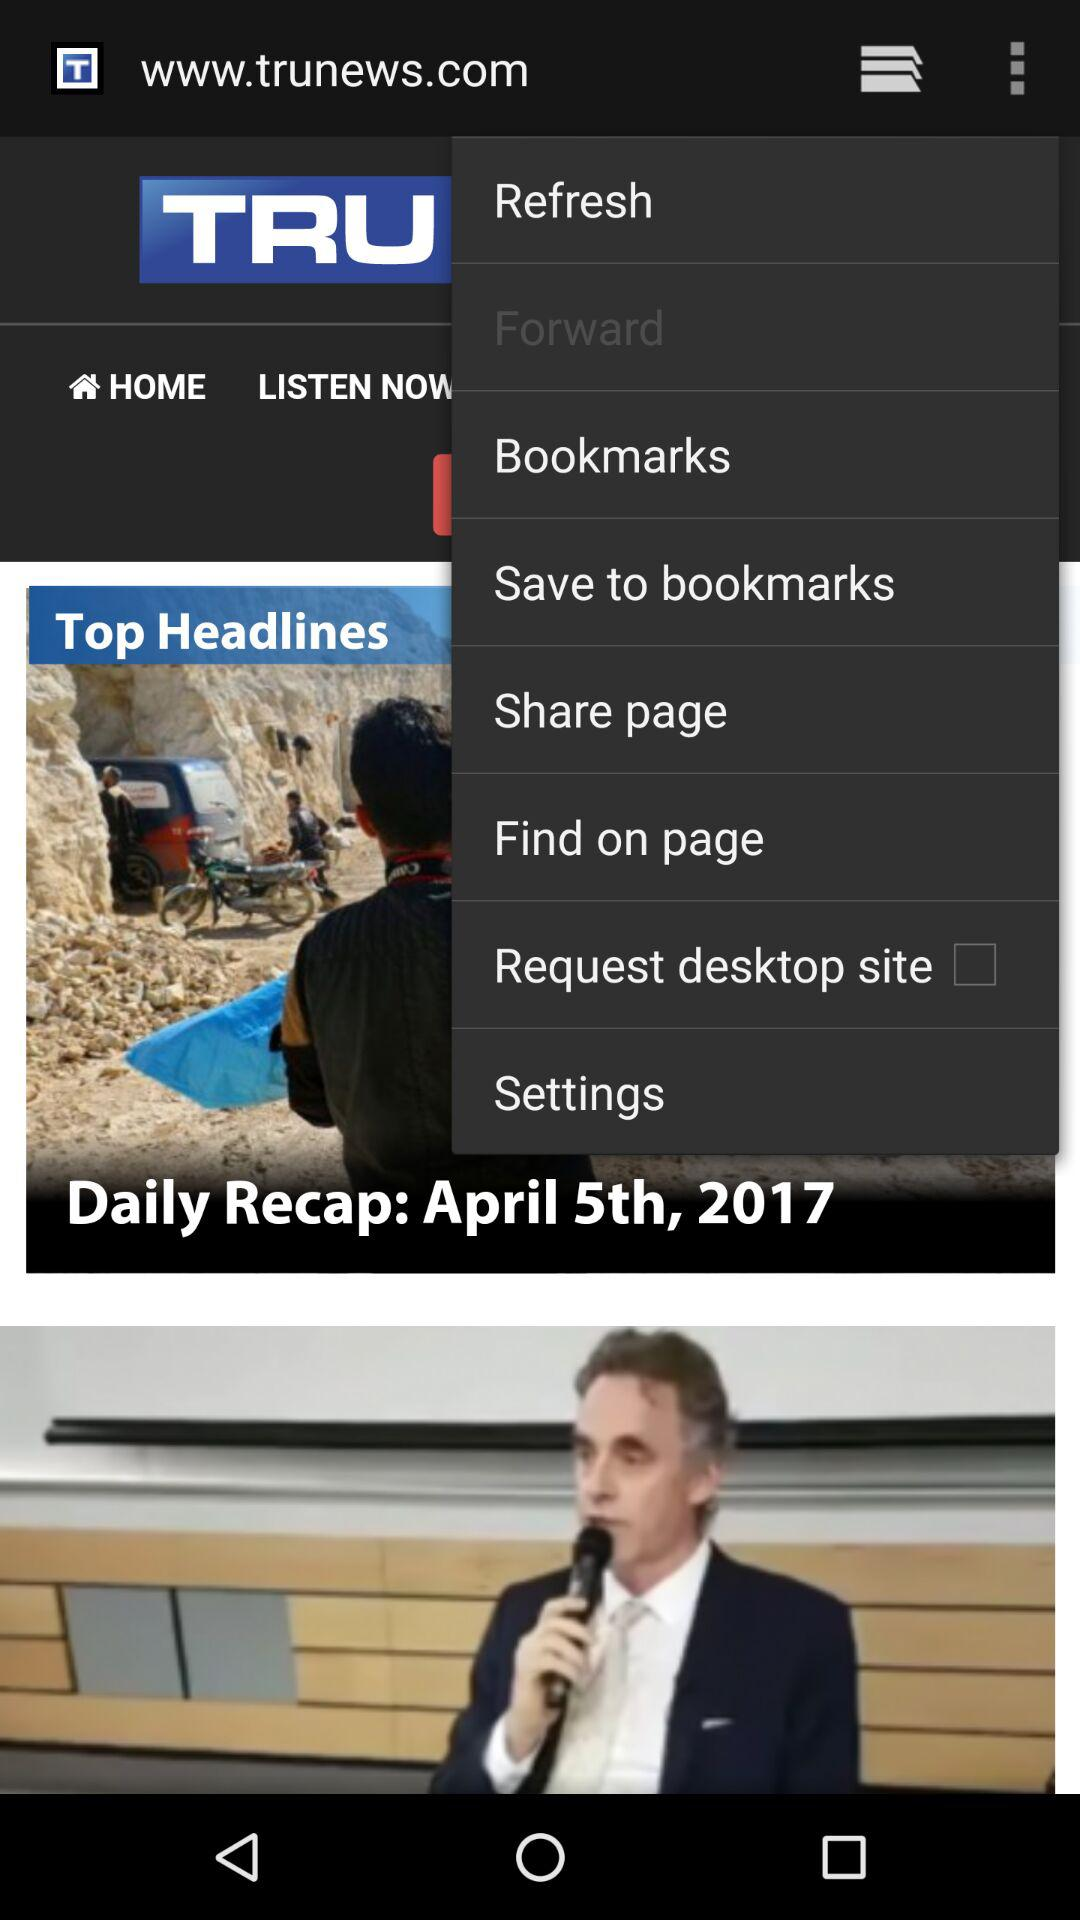For what date is the news "Daily Recap" shown on the screen? The "Daily Recap" is shown on the screen for April 5, 2017. 